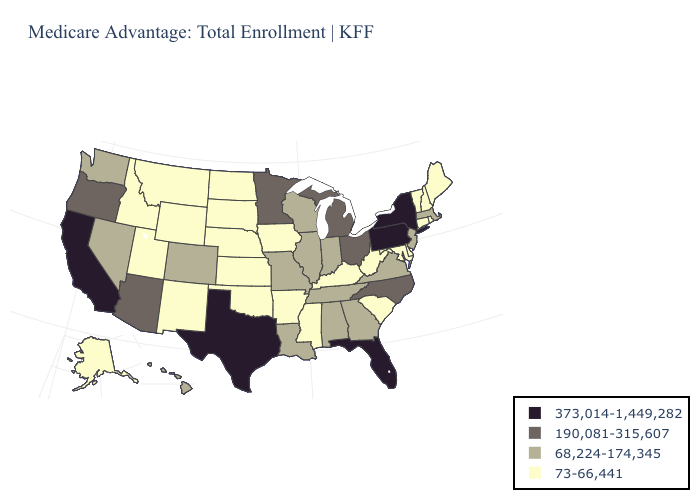What is the lowest value in the MidWest?
Answer briefly. 73-66,441. What is the value of Tennessee?
Answer briefly. 68,224-174,345. Name the states that have a value in the range 190,081-315,607?
Give a very brief answer. Arizona, Michigan, Minnesota, North Carolina, Ohio, Oregon. What is the highest value in states that border Utah?
Keep it brief. 190,081-315,607. Which states hav the highest value in the West?
Quick response, please. California. Name the states that have a value in the range 373,014-1,449,282?
Write a very short answer. California, Florida, New York, Pennsylvania, Texas. Among the states that border Missouri , does Arkansas have the highest value?
Quick response, please. No. Name the states that have a value in the range 73-66,441?
Keep it brief. Alaska, Arkansas, Connecticut, Delaware, Iowa, Idaho, Kansas, Kentucky, Maryland, Maine, Mississippi, Montana, North Dakota, Nebraska, New Hampshire, New Mexico, Oklahoma, Rhode Island, South Carolina, South Dakota, Utah, Vermont, West Virginia, Wyoming. Which states have the lowest value in the West?
Answer briefly. Alaska, Idaho, Montana, New Mexico, Utah, Wyoming. What is the highest value in states that border Nevada?
Keep it brief. 373,014-1,449,282. What is the highest value in the USA?
Concise answer only. 373,014-1,449,282. Does Tennessee have a higher value than Georgia?
Be succinct. No. What is the value of Texas?
Give a very brief answer. 373,014-1,449,282. How many symbols are there in the legend?
Give a very brief answer. 4. Does California have the highest value in the West?
Concise answer only. Yes. 